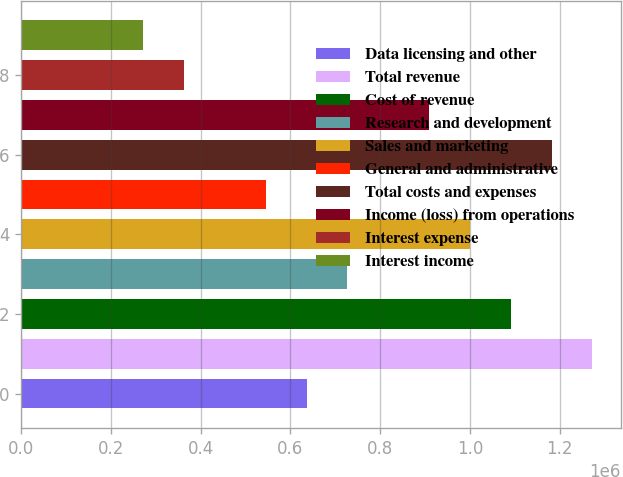Convert chart. <chart><loc_0><loc_0><loc_500><loc_500><bar_chart><fcel>Data licensing and other<fcel>Total revenue<fcel>Cost of revenue<fcel>Research and development<fcel>Sales and marketing<fcel>General and administrative<fcel>Total costs and expenses<fcel>Income (loss) from operations<fcel>Interest expense<fcel>Interest income<nl><fcel>636185<fcel>1.27237e+06<fcel>1.0906e+06<fcel>727069<fcel>999720<fcel>545302<fcel>1.18149e+06<fcel>908836<fcel>363535<fcel>272651<nl></chart> 